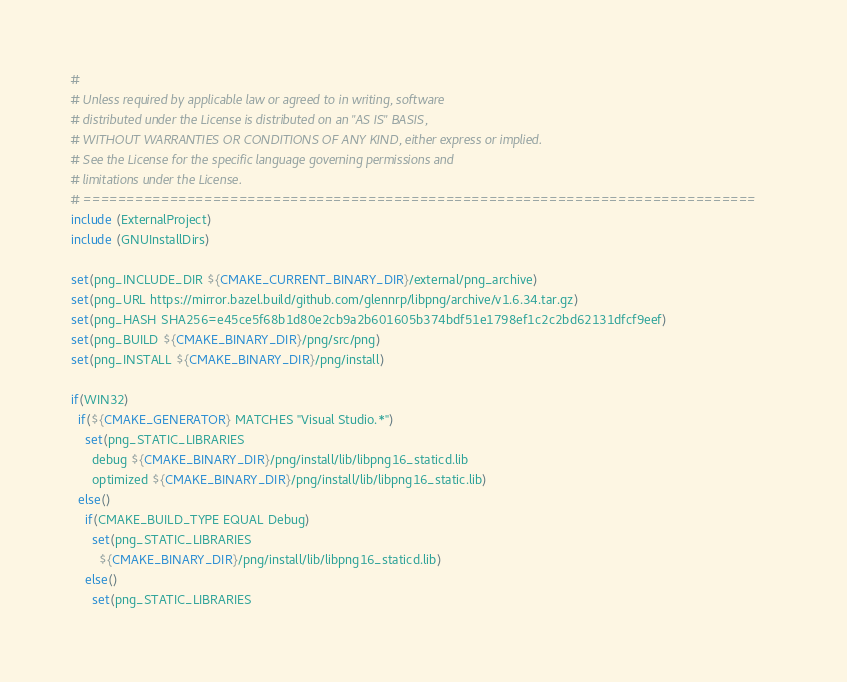Convert code to text. <code><loc_0><loc_0><loc_500><loc_500><_CMake_>#
# Unless required by applicable law or agreed to in writing, software
# distributed under the License is distributed on an "AS IS" BASIS,
# WITHOUT WARRANTIES OR CONDITIONS OF ANY KIND, either express or implied.
# See the License for the specific language governing permissions and
# limitations under the License.
# ==============================================================================
include (ExternalProject)
include (GNUInstallDirs)

set(png_INCLUDE_DIR ${CMAKE_CURRENT_BINARY_DIR}/external/png_archive)
set(png_URL https://mirror.bazel.build/github.com/glennrp/libpng/archive/v1.6.34.tar.gz)
set(png_HASH SHA256=e45ce5f68b1d80e2cb9a2b601605b374bdf51e1798ef1c2c2bd62131dfcf9eef)
set(png_BUILD ${CMAKE_BINARY_DIR}/png/src/png)
set(png_INSTALL ${CMAKE_BINARY_DIR}/png/install)

if(WIN32)
  if(${CMAKE_GENERATOR} MATCHES "Visual Studio.*")
    set(png_STATIC_LIBRARIES 
      debug ${CMAKE_BINARY_DIR}/png/install/lib/libpng16_staticd.lib
      optimized ${CMAKE_BINARY_DIR}/png/install/lib/libpng16_static.lib)
  else()
    if(CMAKE_BUILD_TYPE EQUAL Debug)
      set(png_STATIC_LIBRARIES 
        ${CMAKE_BINARY_DIR}/png/install/lib/libpng16_staticd.lib)
    else()
      set(png_STATIC_LIBRARIES </code> 